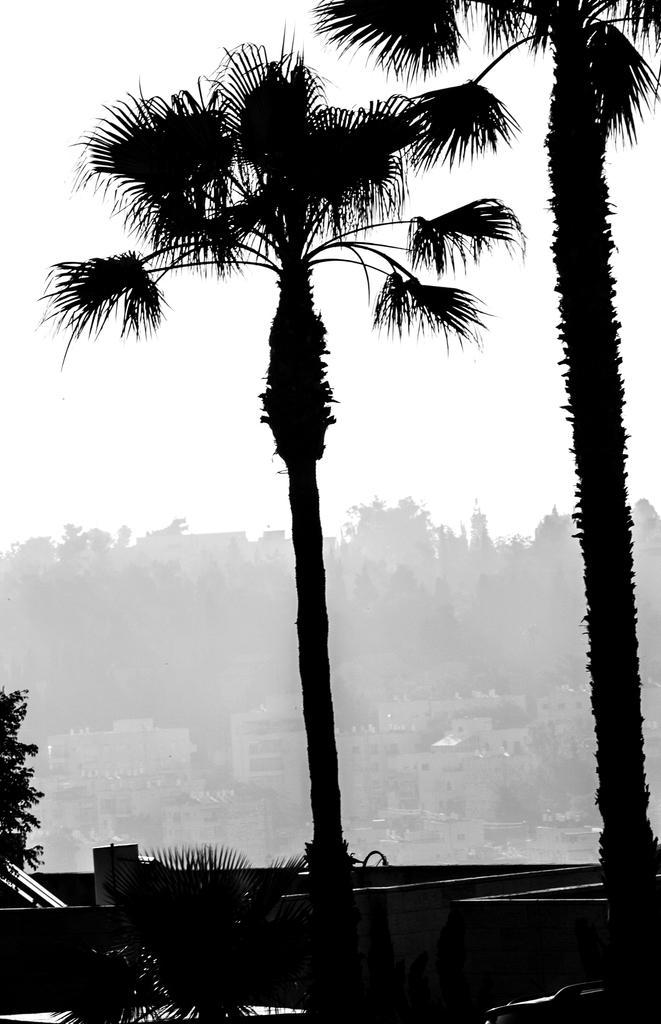How would you summarize this image in a sentence or two? In the center of the image there is a tree. On the right side of the image we can see tree. In the background there are buildings, trees and sky. 